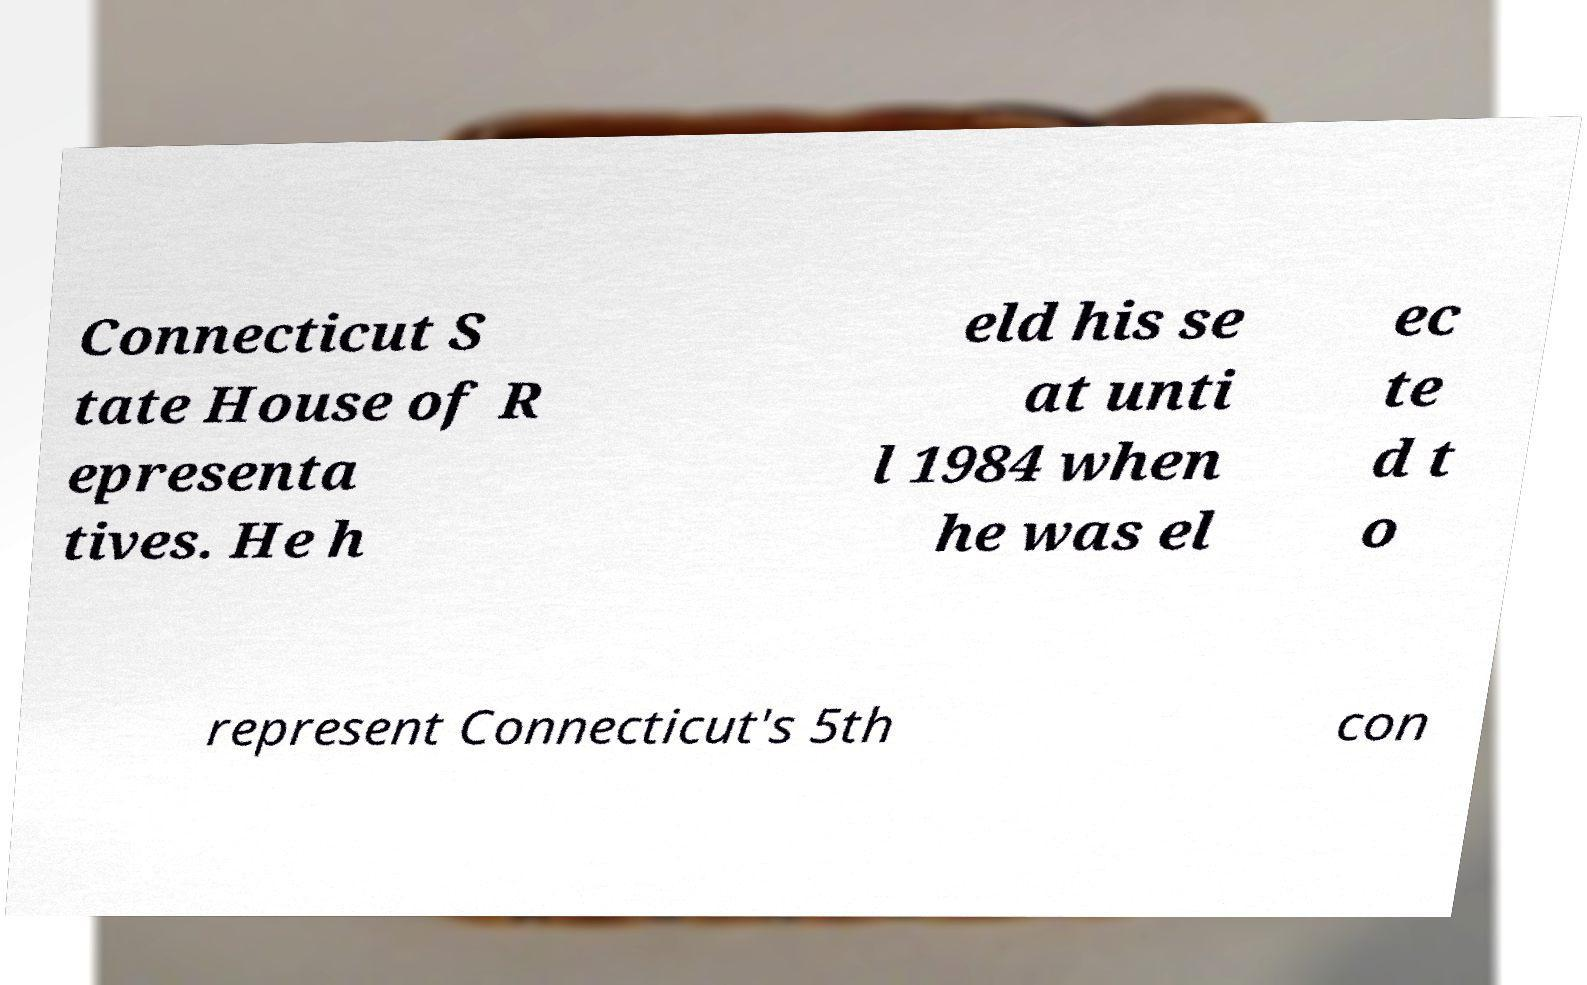I need the written content from this picture converted into text. Can you do that? Connecticut S tate House of R epresenta tives. He h eld his se at unti l 1984 when he was el ec te d t o represent Connecticut's 5th con 